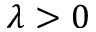<formula> <loc_0><loc_0><loc_500><loc_500>\lambda > 0</formula> 